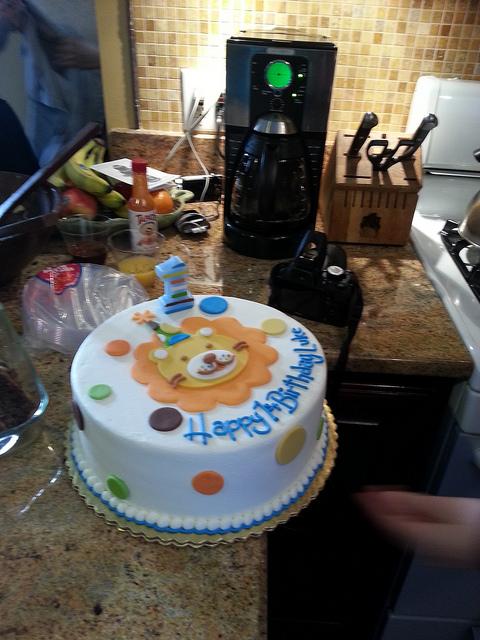What number candle is on the cake?
Keep it brief. 1. What fruit is on top of the cake?
Answer briefly. 0. What is the animal on the cake?
Answer briefly. Lion. Whose birthday is this?
Short answer required. Luke. 